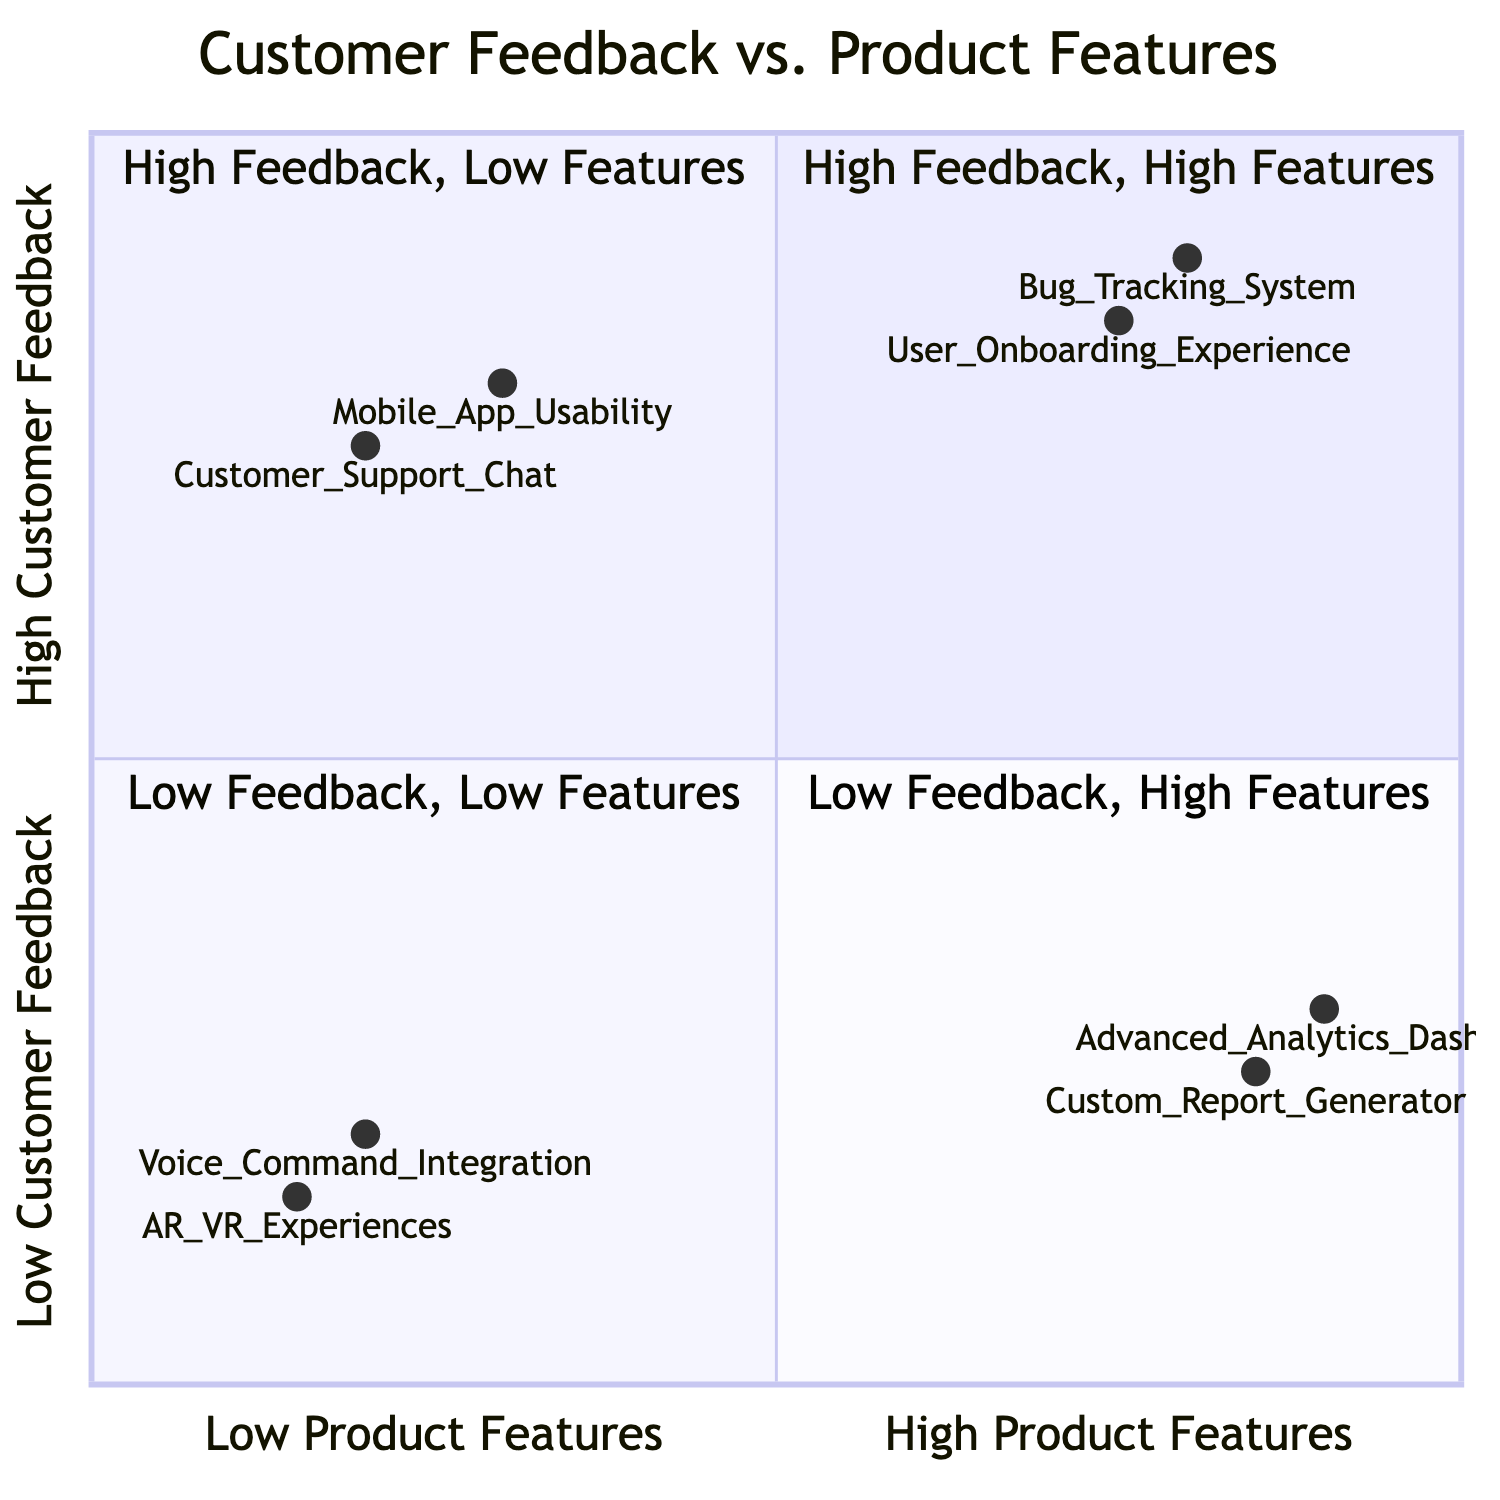What are the two elements in the High Customer Feedback, High Product Features quadrant? By referring to the quadrant titled "High Customer Feedback, High Product Features," we can see that it has two elements listed: "Bug Tracking System" and "User Onboarding Experience." They are explicitly mentioned under this quadrant.
Answer: Bug Tracking System, User Onboarding Experience Which element has low customer feedback but high product features? Looking at the quadrant labeled "Low Customer Feedback, High Product Features," we find two elements listed: "Advanced Analytics Dashboard" and "Custom Report Generator." This highlights that these elements fit the criteria provided.
Answer: Advanced Analytics Dashboard, Custom Report Generator What is the level of customer feedback for Mobile App Usability? In the quadrant titled "High Customer Feedback, Low Product Features," we can see the position of "Mobile App Usability" marked as having a customer feedback level, specifically on the y-axis, ranked at 0.8. This reflects its position within the quadrant.
Answer: 0.8 How many elements are there in the Low Customer Feedback, Low Product Features quadrant? The quadrant "Low Customer Feedback, Low Product Features" includes two elements: "Voice Command Integration" and "AR/VR Experiences." As both are listed, it clarifies the quantity present in this quadrant.
Answer: 2 In which quadrant does Customer Support Chat appear? Customer Support Chat is positioned in the "High Customer Feedback, Low Product Features" quadrant, as indicated by its inclusion under this specific quadrant title. This is a straightforward identification based on the diagram.
Answer: High Customer Feedback, Low Product Features Which quadrant contains elements with minimal customer engagement despite having numerous features? The "Low Customer Feedback, High Product Features" quadrant contains the elements "Advanced Analytics Dashboard" and "Custom Report Generator," highlighting that these have many features but low customer interest as stated in their descriptions.
Answer: Low Customer Feedback, High Product Features What is the primary reason given for feedback on User Onboarding Experience? The description under the "High Customer Feedback, High Product Features" quadrant for "User Onboarding Experience" cites a high demand for guided tutorials and step-by-step onboarding, indicating the reason for the feedback.
Answer: High demand for guided tutorials and step-by-step onboarding How many quadrants are in the diagram? The diagram contains four distinct quadrants, which can be counted as follows: High Customer Feedback, High Product Features; High Customer Feedback, Low Product Features; Low Customer Feedback, Low Product Features; Low Customer Feedback, High Product Features. These represent the differing combinations of feedback and features.
Answer: 4 